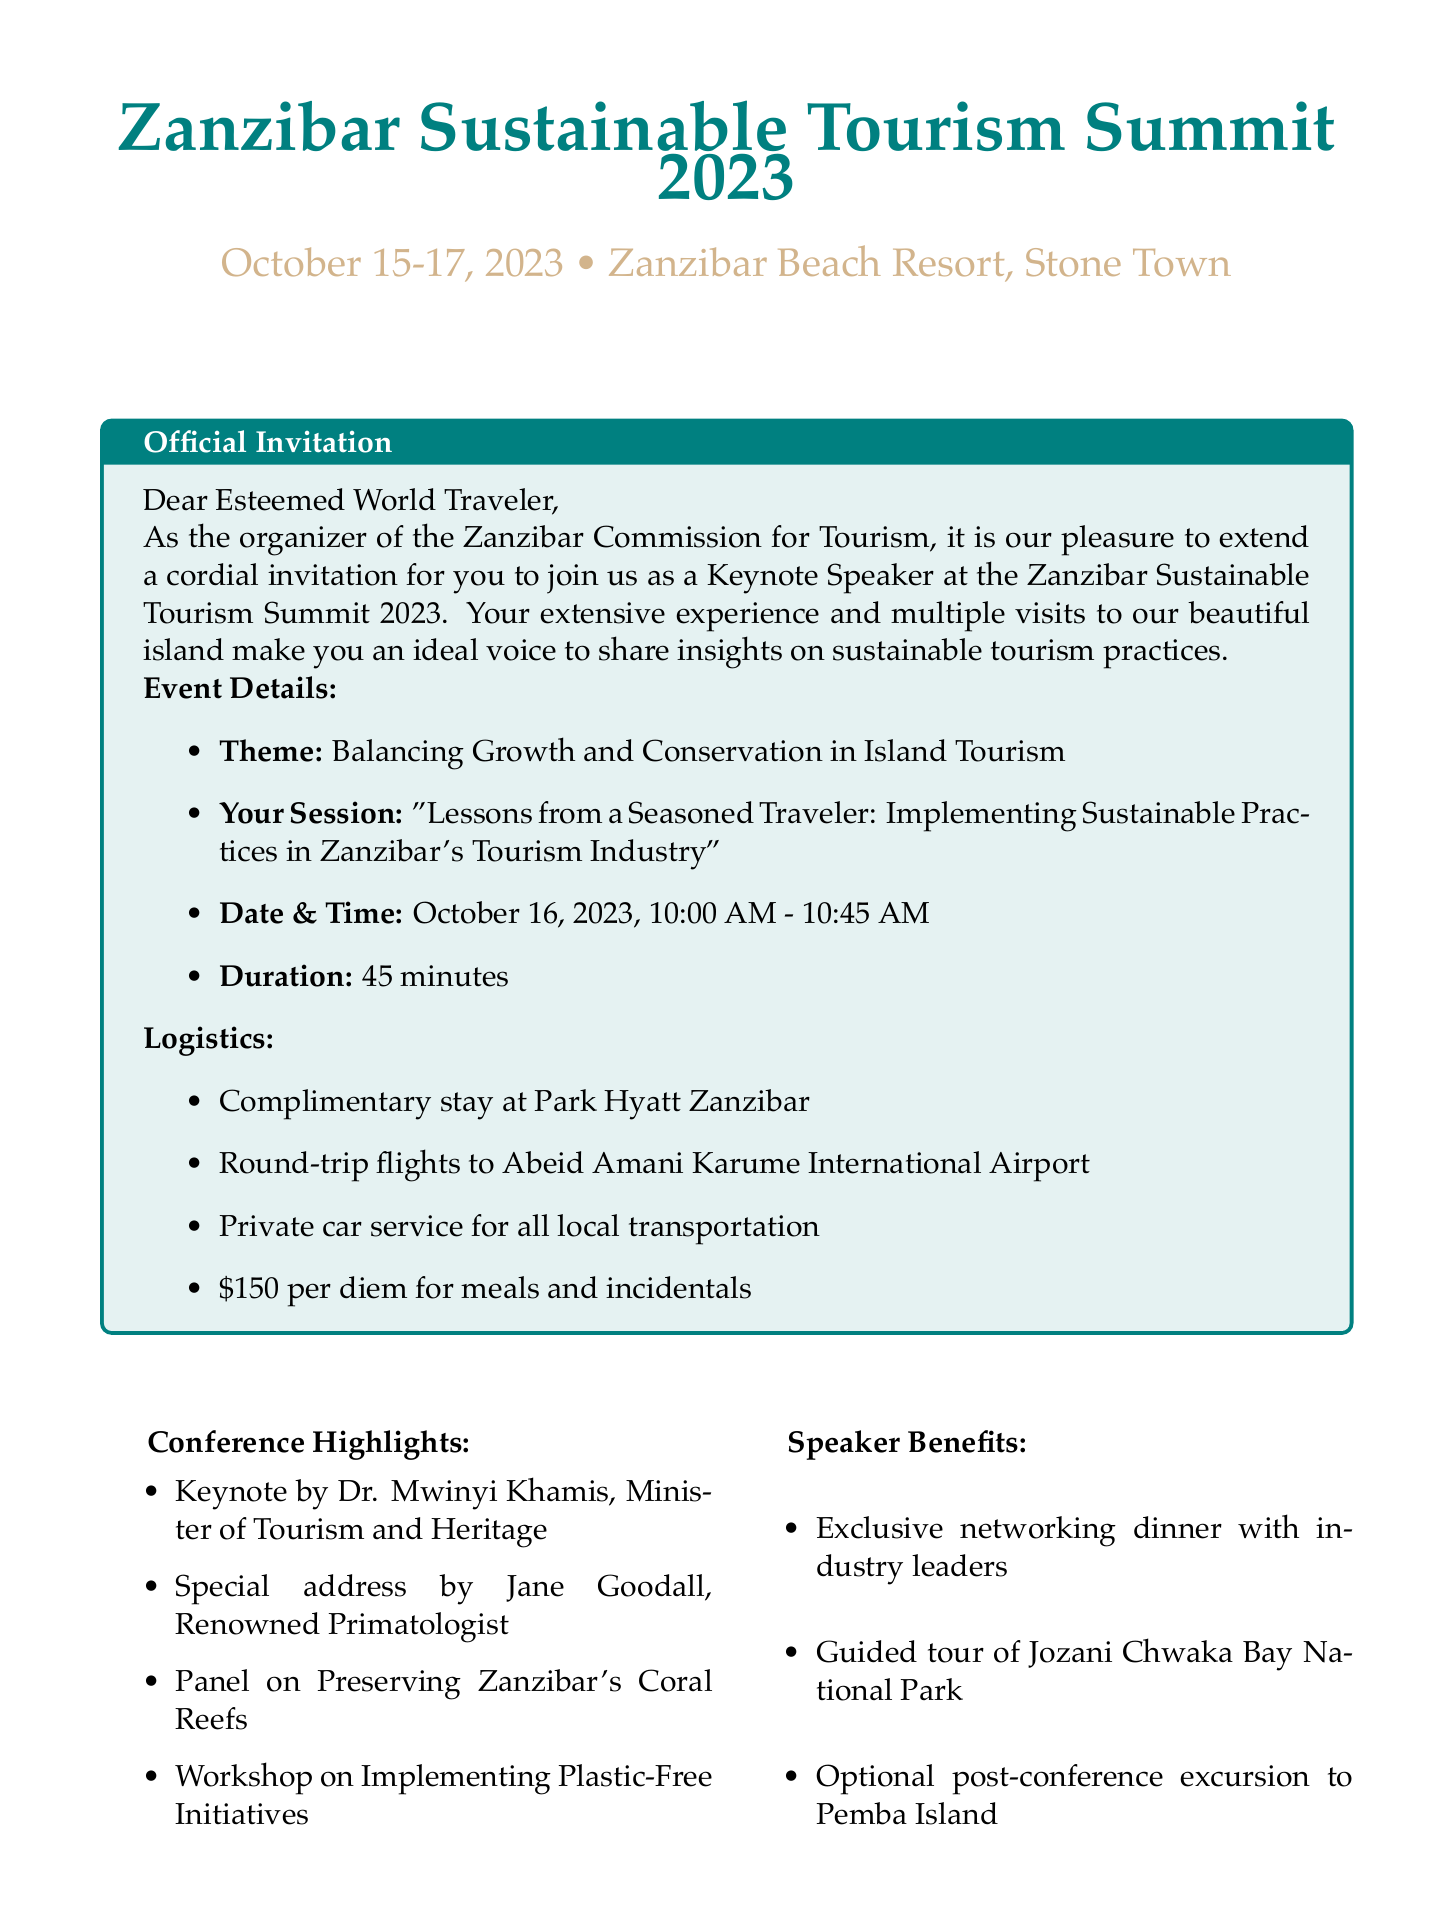What is the name of the conference? The name of the conference is explicitly stated in the document.
Answer: Zanzibar Sustainable Tourism Summit 2023 When will the event take place? The date of the event is provided in the event details section.
Answer: October 15-17, 2023 Who is the organizer of the conference? The organizer is mentioned in the introduction of the document.
Answer: Zanzibar Commission for Tourism What is the session duration for the keynote speech? The duration of the keynote session is listed in the invitation context.
Answer: 45 minutes What is the theme of the conference? The theme is noted under the event details.
Answer: Balancing Growth and Conservation in Island Tourism What is included in the speaker benefits? The document lists various benefits for speakers.
Answer: Exclusive dinner with industry leaders Who will give a special address at the conference? The document specifically mentions a notable speaker with a special address.
Answer: Jane Goodall What type of transportation is provided for local transfers? The logistics section specifies the type of transportation included.
Answer: Private car service What is one personal touch suggested for the speaker? The document lists personal touches to share unique perspectives.
Answer: Experiences at Chumbe Island Coral Park What is the expected number of attendees? This information is provided in the conference impact section.
Answer: 500+ tourism professionals 